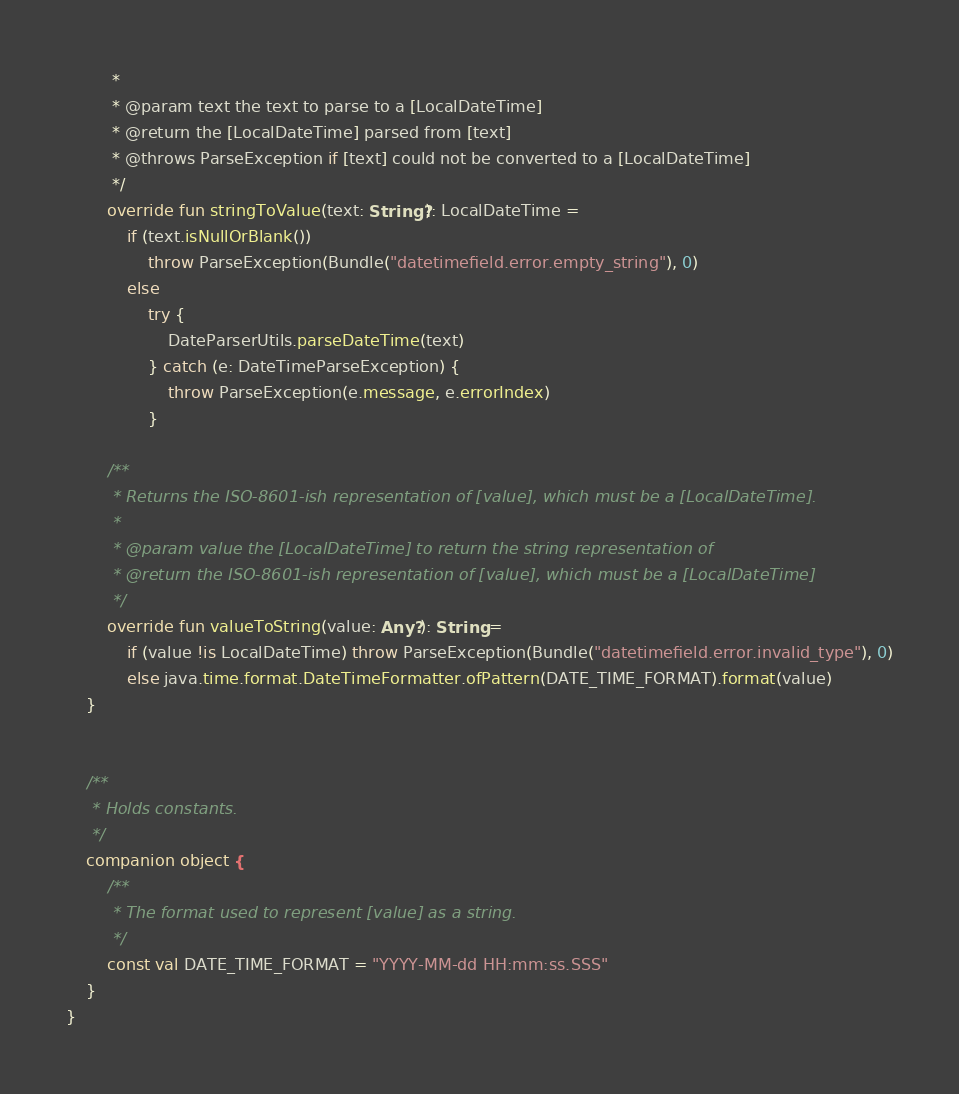<code> <loc_0><loc_0><loc_500><loc_500><_Kotlin_>         *
         * @param text the text to parse to a [LocalDateTime]
         * @return the [LocalDateTime] parsed from [text]
         * @throws ParseException if [text] could not be converted to a [LocalDateTime]
         */
        override fun stringToValue(text: String?): LocalDateTime =
            if (text.isNullOrBlank())
                throw ParseException(Bundle("datetimefield.error.empty_string"), 0)
            else
                try {
                    DateParserUtils.parseDateTime(text)
                } catch (e: DateTimeParseException) {
                    throw ParseException(e.message, e.errorIndex)
                }

        /**
         * Returns the ISO-8601-ish representation of [value], which must be a [LocalDateTime].
         *
         * @param value the [LocalDateTime] to return the string representation of
         * @return the ISO-8601-ish representation of [value], which must be a [LocalDateTime]
         */
        override fun valueToString(value: Any?): String =
            if (value !is LocalDateTime) throw ParseException(Bundle("datetimefield.error.invalid_type"), 0)
            else java.time.format.DateTimeFormatter.ofPattern(DATE_TIME_FORMAT).format(value)
    }


    /**
     * Holds constants.
     */
    companion object {
        /**
         * The format used to represent [value] as a string.
         */
        const val DATE_TIME_FORMAT = "YYYY-MM-dd HH:mm:ss.SSS"
    }
}
</code> 